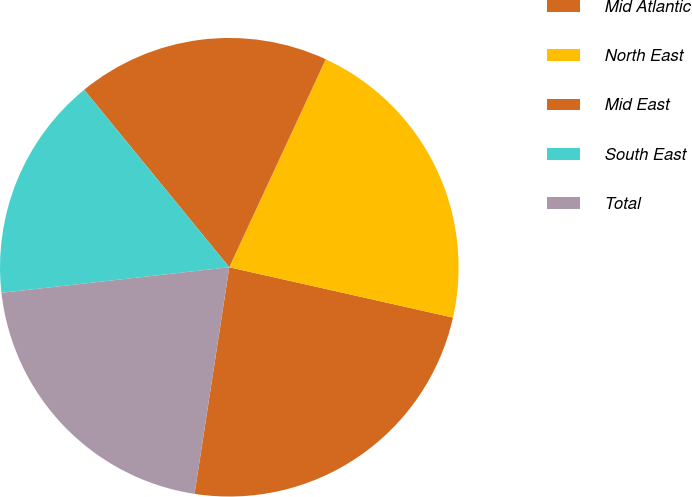Convert chart to OTSL. <chart><loc_0><loc_0><loc_500><loc_500><pie_chart><fcel>Mid Atlantic<fcel>North East<fcel>Mid East<fcel>South East<fcel>Total<nl><fcel>23.9%<fcel>21.61%<fcel>17.82%<fcel>15.87%<fcel>20.8%<nl></chart> 